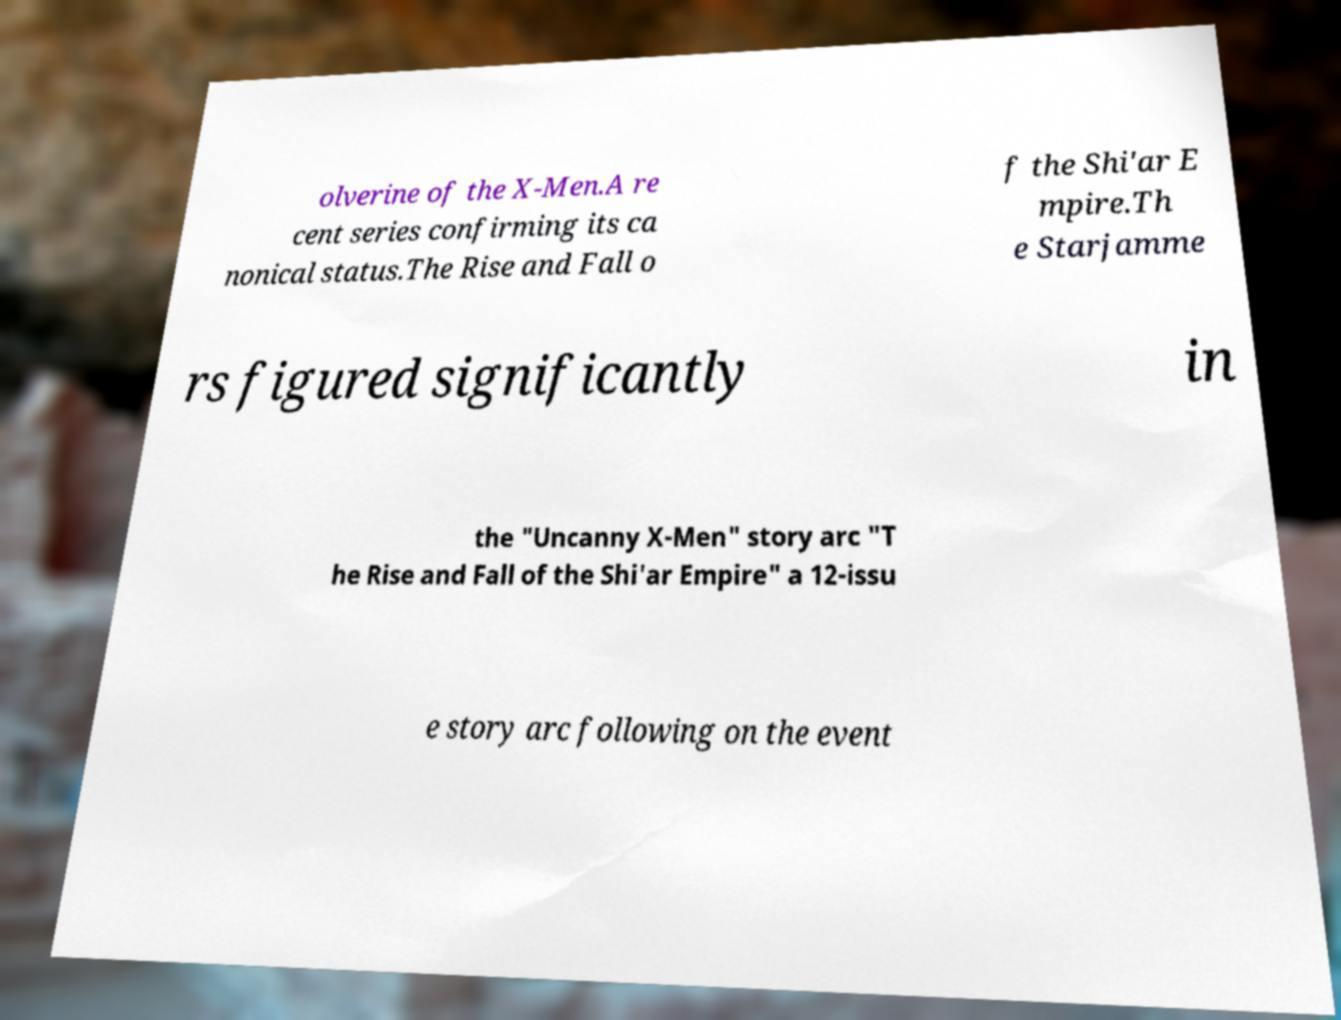Can you read and provide the text displayed in the image?This photo seems to have some interesting text. Can you extract and type it out for me? olverine of the X-Men.A re cent series confirming its ca nonical status.The Rise and Fall o f the Shi'ar E mpire.Th e Starjamme rs figured significantly in the "Uncanny X-Men" story arc "T he Rise and Fall of the Shi'ar Empire" a 12-issu e story arc following on the event 